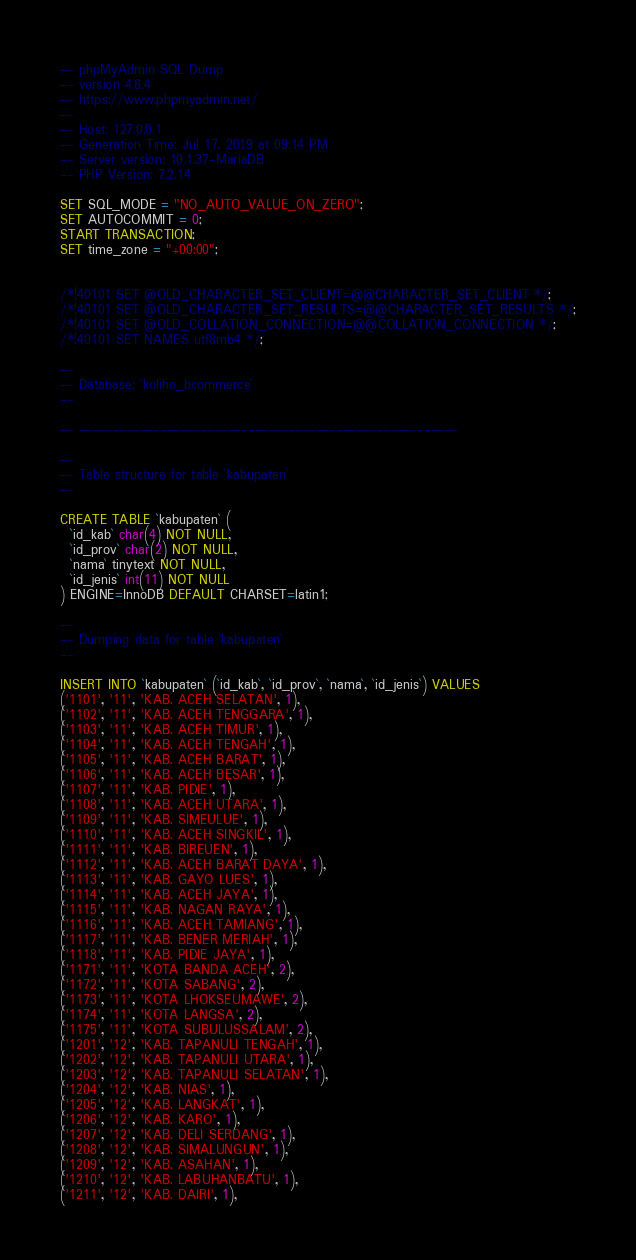<code> <loc_0><loc_0><loc_500><loc_500><_SQL_>-- phpMyAdmin SQL Dump
-- version 4.8.4
-- https://www.phpmyadmin.net/
--
-- Host: 127.0.0.1
-- Generation Time: Jul 17, 2019 at 09:14 PM
-- Server version: 10.1.37-MariaDB
-- PHP Version: 7.2.14

SET SQL_MODE = "NO_AUTO_VALUE_ON_ZERO";
SET AUTOCOMMIT = 0;
START TRANSACTION;
SET time_zone = "+00:00";


/*!40101 SET @OLD_CHARACTER_SET_CLIENT=@@CHARACTER_SET_CLIENT */;
/*!40101 SET @OLD_CHARACTER_SET_RESULTS=@@CHARACTER_SET_RESULTS */;
/*!40101 SET @OLD_COLLATION_CONNECTION=@@COLLATION_CONNECTION */;
/*!40101 SET NAMES utf8mb4 */;

--
-- Database: `koliho_bcommerce`
--

-- --------------------------------------------------------

--
-- Table structure for table `kabupaten`
--

CREATE TABLE `kabupaten` (
  `id_kab` char(4) NOT NULL,
  `id_prov` char(2) NOT NULL,
  `nama` tinytext NOT NULL,
  `id_jenis` int(11) NOT NULL
) ENGINE=InnoDB DEFAULT CHARSET=latin1;

--
-- Dumping data for table `kabupaten`
--

INSERT INTO `kabupaten` (`id_kab`, `id_prov`, `nama`, `id_jenis`) VALUES
('1101', '11', 'KAB. ACEH SELATAN', 1),
('1102', '11', 'KAB. ACEH TENGGARA', 1),
('1103', '11', 'KAB. ACEH TIMUR', 1),
('1104', '11', 'KAB. ACEH TENGAH', 1),
('1105', '11', 'KAB. ACEH BARAT', 1),
('1106', '11', 'KAB. ACEH BESAR', 1),
('1107', '11', 'KAB. PIDIE', 1),
('1108', '11', 'KAB. ACEH UTARA', 1),
('1109', '11', 'KAB. SIMEULUE', 1),
('1110', '11', 'KAB. ACEH SINGKIL', 1),
('1111', '11', 'KAB. BIREUEN', 1),
('1112', '11', 'KAB. ACEH BARAT DAYA', 1),
('1113', '11', 'KAB. GAYO LUES', 1),
('1114', '11', 'KAB. ACEH JAYA', 1),
('1115', '11', 'KAB. NAGAN RAYA', 1),
('1116', '11', 'KAB. ACEH TAMIANG', 1),
('1117', '11', 'KAB. BENER MERIAH', 1),
('1118', '11', 'KAB. PIDIE JAYA', 1),
('1171', '11', 'KOTA BANDA ACEH', 2),
('1172', '11', 'KOTA SABANG', 2),
('1173', '11', 'KOTA LHOKSEUMAWE', 2),
('1174', '11', 'KOTA LANGSA', 2),
('1175', '11', 'KOTA SUBULUSSALAM', 2),
('1201', '12', 'KAB. TAPANULI TENGAH', 1),
('1202', '12', 'KAB. TAPANULI UTARA', 1),
('1203', '12', 'KAB. TAPANULI SELATAN', 1),
('1204', '12', 'KAB. NIAS', 1),
('1205', '12', 'KAB. LANGKAT', 1),
('1206', '12', 'KAB. KARO', 1),
('1207', '12', 'KAB. DELI SERDANG', 1),
('1208', '12', 'KAB. SIMALUNGUN', 1),
('1209', '12', 'KAB. ASAHAN', 1),
('1210', '12', 'KAB. LABUHANBATU', 1),
('1211', '12', 'KAB. DAIRI', 1),</code> 